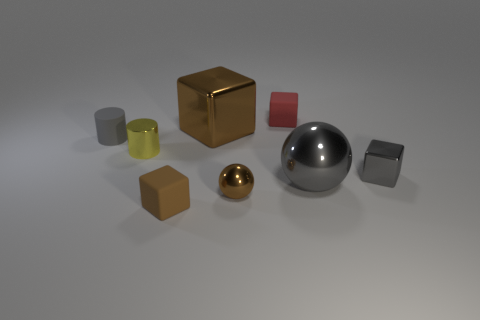Can you describe the arrangement of the objects on the surface in terms of their colors and materials? The objects are arranged sporadically on a light colored surface. There are two cubes, one is gold and reflective, while the other is brown and has a matte finish. There are also two cylinders, one large and gray, the other small and yellow, both having matte finishes. At the center, there's a large silver reflective sphere, and a smaller gold reflective sphere near it. Lastly, there's a small gray cube with a matte finish. 